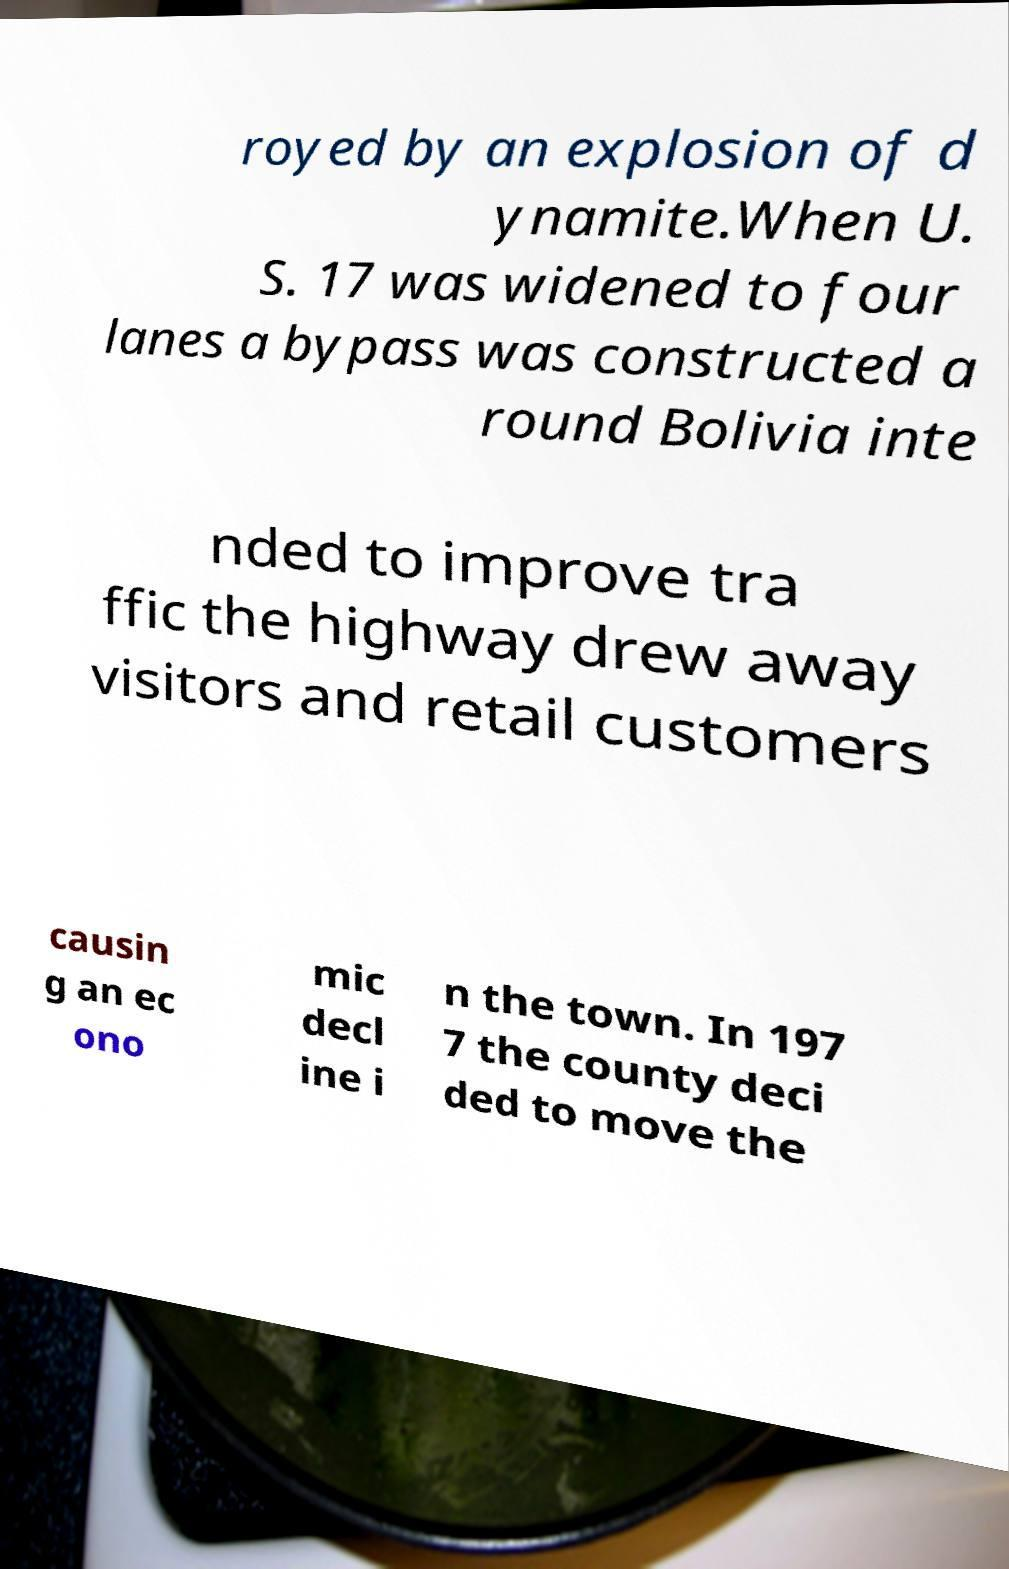Can you accurately transcribe the text from the provided image for me? royed by an explosion of d ynamite.When U. S. 17 was widened to four lanes a bypass was constructed a round Bolivia inte nded to improve tra ffic the highway drew away visitors and retail customers causin g an ec ono mic decl ine i n the town. In 197 7 the county deci ded to move the 